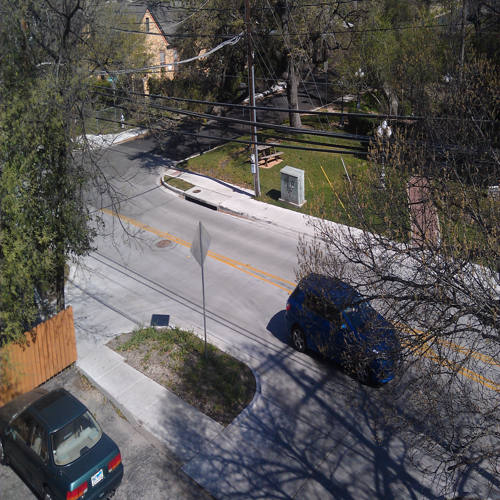What is the quality of this image?
A. Excellent
B. Very good
C. Poor The quality of the image is better described as 'Very good' (Option B). The image is clear and the details are quite discernible, though there is room for improvement, such as better lighting or a higher resolution for the finer details. 